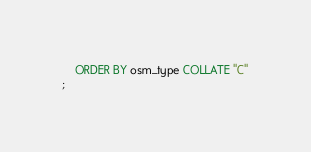<code> <loc_0><loc_0><loc_500><loc_500><_SQL_>    ORDER BY osm_type COLLATE "C"
;</code> 